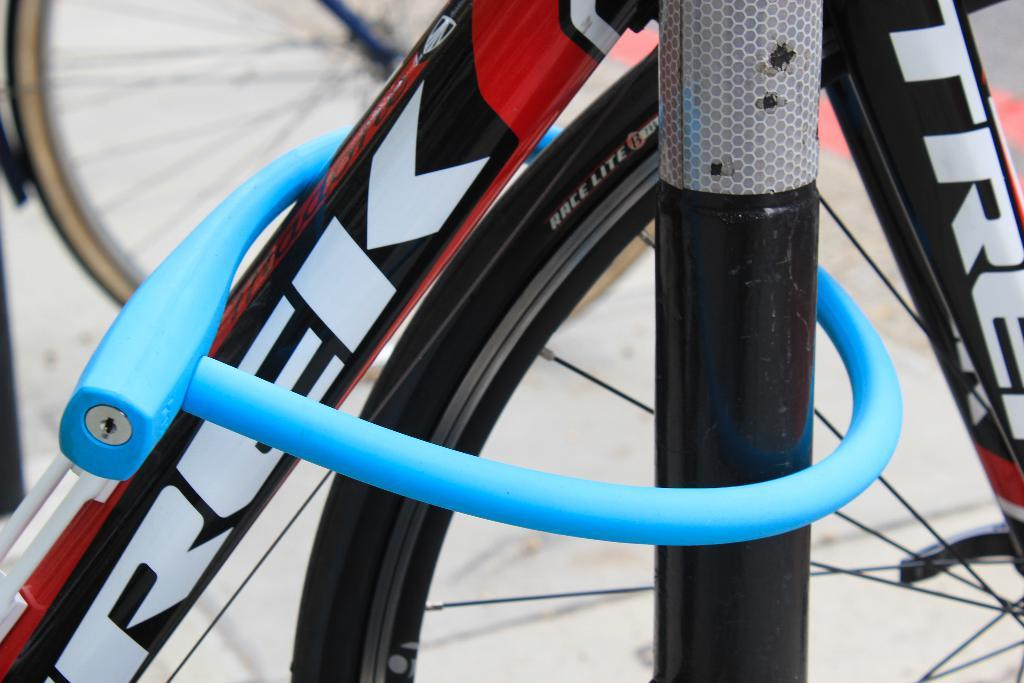What type of vehicles are in the image? There are bicycles in the image. What is written on the bicycles? There is text written on the bicycles. What can be seen at the bottom of the image? The image shows a road at the bottom. How many buckets are being used to carry the bicycles in the image? There are no buckets present in the image; the bicycles are not being carried. What type of conversation is happening between the bicycles in the image? There is no conversation happening between the bicycles in the image, as they are inanimate objects. 